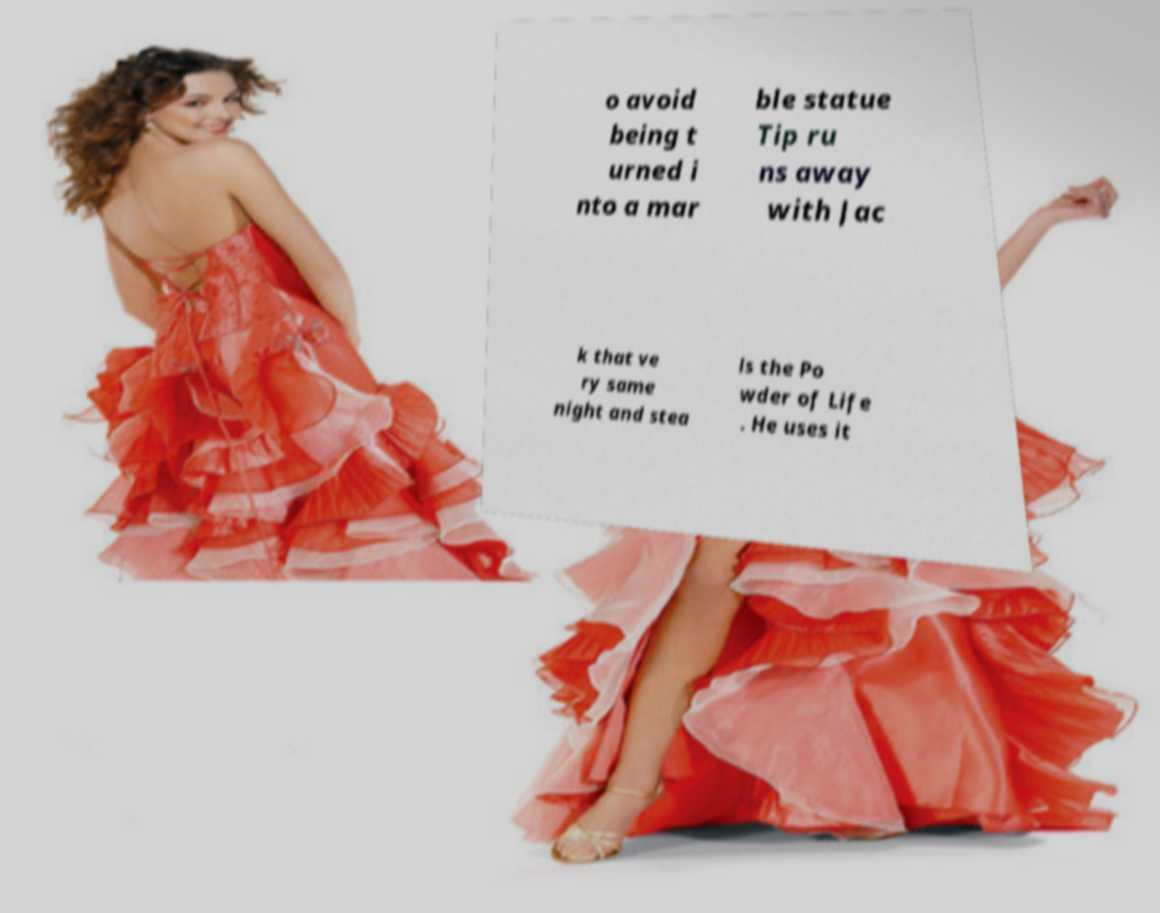I need the written content from this picture converted into text. Can you do that? o avoid being t urned i nto a mar ble statue Tip ru ns away with Jac k that ve ry same night and stea ls the Po wder of Life . He uses it 